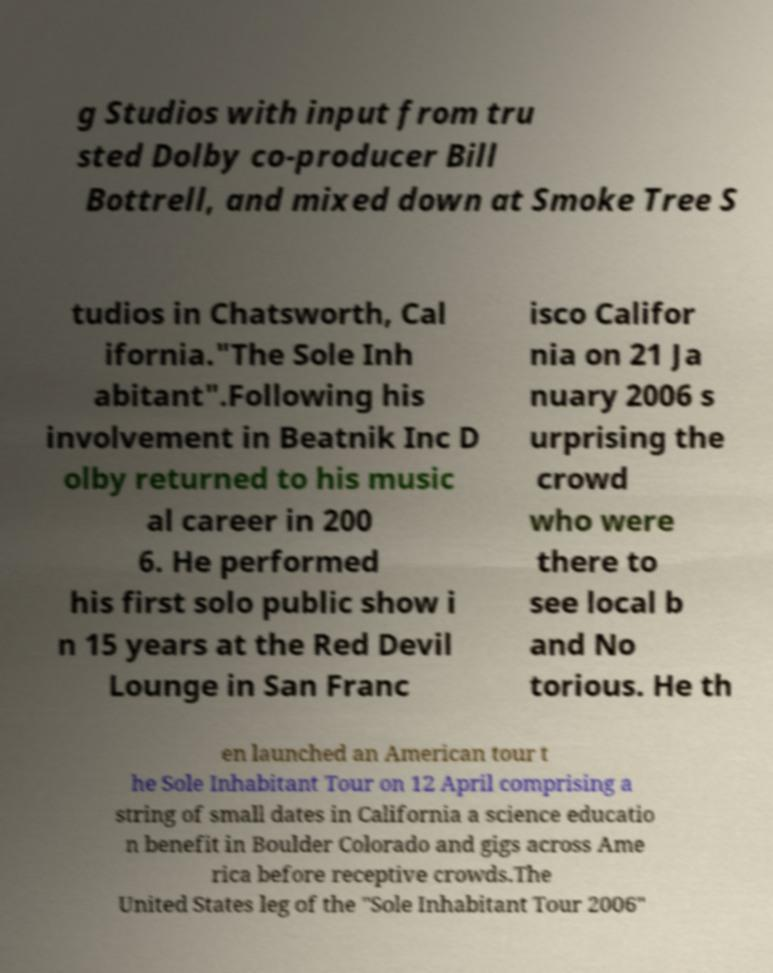Could you assist in decoding the text presented in this image and type it out clearly? g Studios with input from tru sted Dolby co-producer Bill Bottrell, and mixed down at Smoke Tree S tudios in Chatsworth, Cal ifornia."The Sole Inh abitant".Following his involvement in Beatnik Inc D olby returned to his music al career in 200 6. He performed his first solo public show i n 15 years at the Red Devil Lounge in San Franc isco Califor nia on 21 Ja nuary 2006 s urprising the crowd who were there to see local b and No torious. He th en launched an American tour t he Sole Inhabitant Tour on 12 April comprising a string of small dates in California a science educatio n benefit in Boulder Colorado and gigs across Ame rica before receptive crowds.The United States leg of the "Sole Inhabitant Tour 2006" 